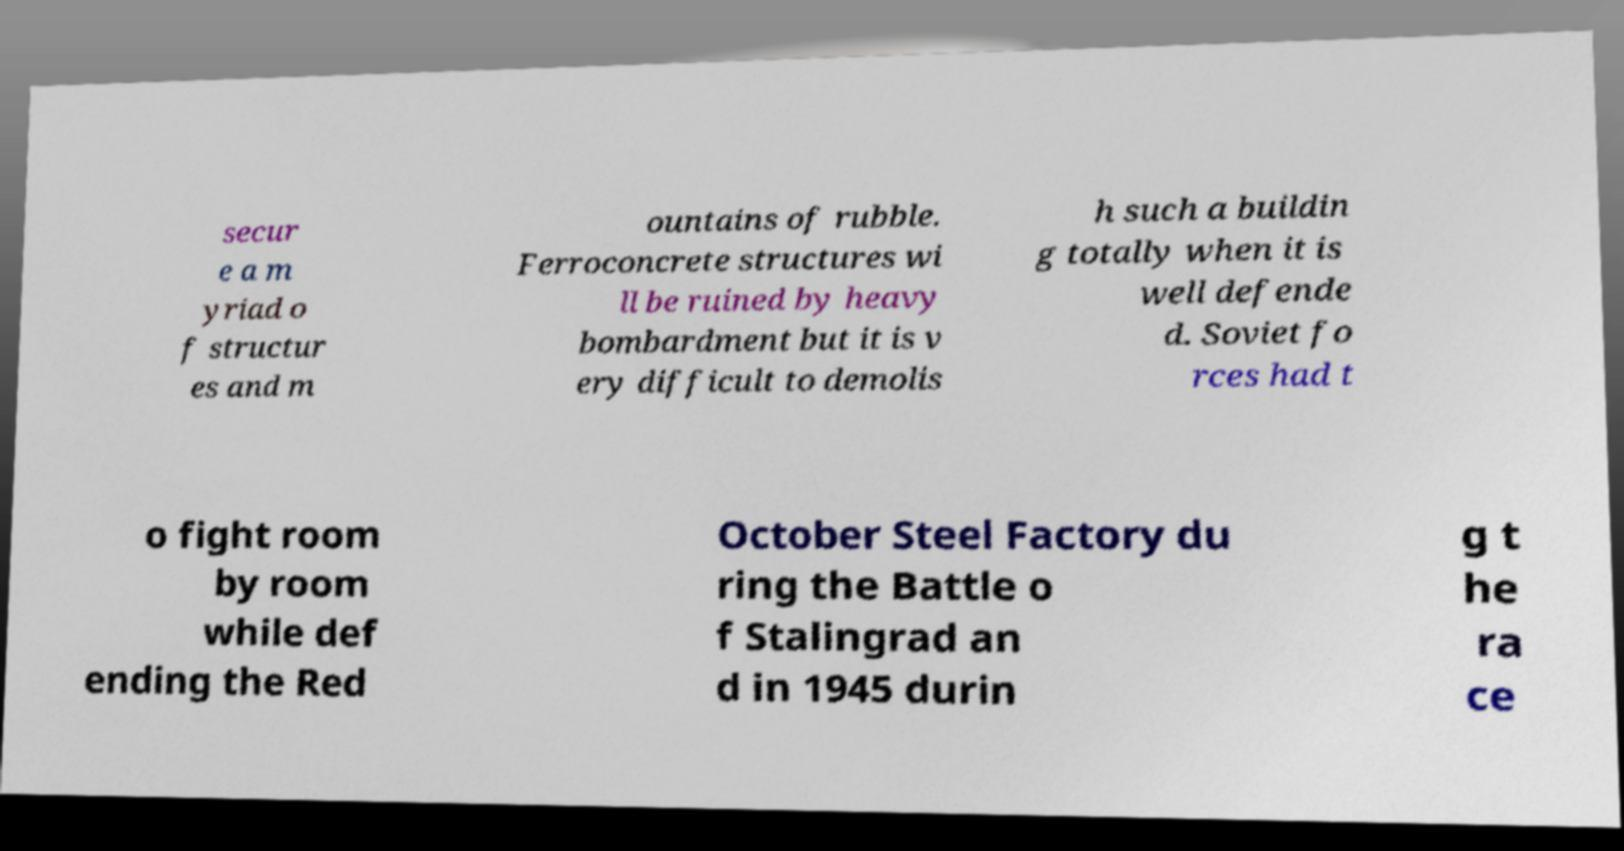Can you read and provide the text displayed in the image?This photo seems to have some interesting text. Can you extract and type it out for me? secur e a m yriad o f structur es and m ountains of rubble. Ferroconcrete structures wi ll be ruined by heavy bombardment but it is v ery difficult to demolis h such a buildin g totally when it is well defende d. Soviet fo rces had t o fight room by room while def ending the Red October Steel Factory du ring the Battle o f Stalingrad an d in 1945 durin g t he ra ce 